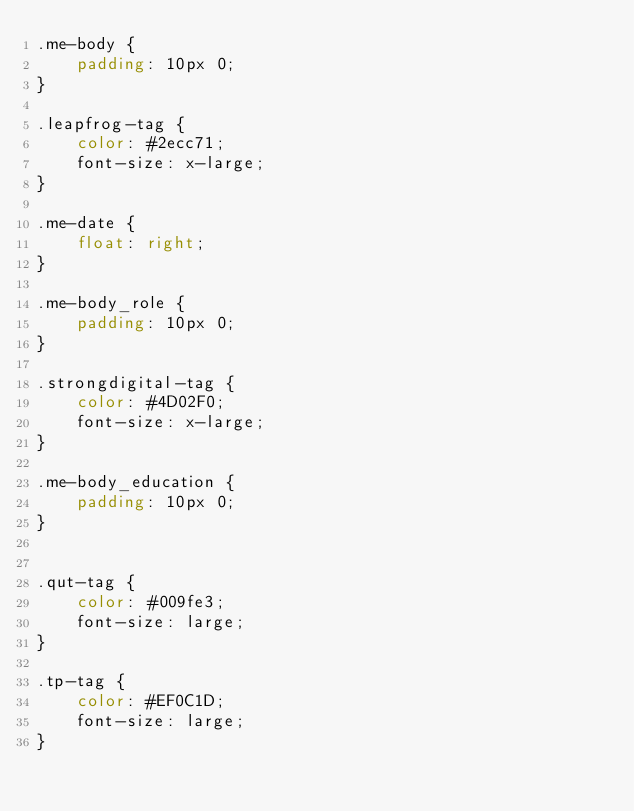Convert code to text. <code><loc_0><loc_0><loc_500><loc_500><_CSS_>.me-body {
    padding: 10px 0;
}

.leapfrog-tag {
    color: #2ecc71;
    font-size: x-large;
}

.me-date {
    float: right;
}

.me-body_role {
    padding: 10px 0;
}

.strongdigital-tag {
    color: #4D02F0;
    font-size: x-large;
}

.me-body_education {
    padding: 10px 0;
}


.qut-tag {
    color: #009fe3;
    font-size: large;
}

.tp-tag {
    color: #EF0C1D;
    font-size: large;
}</code> 